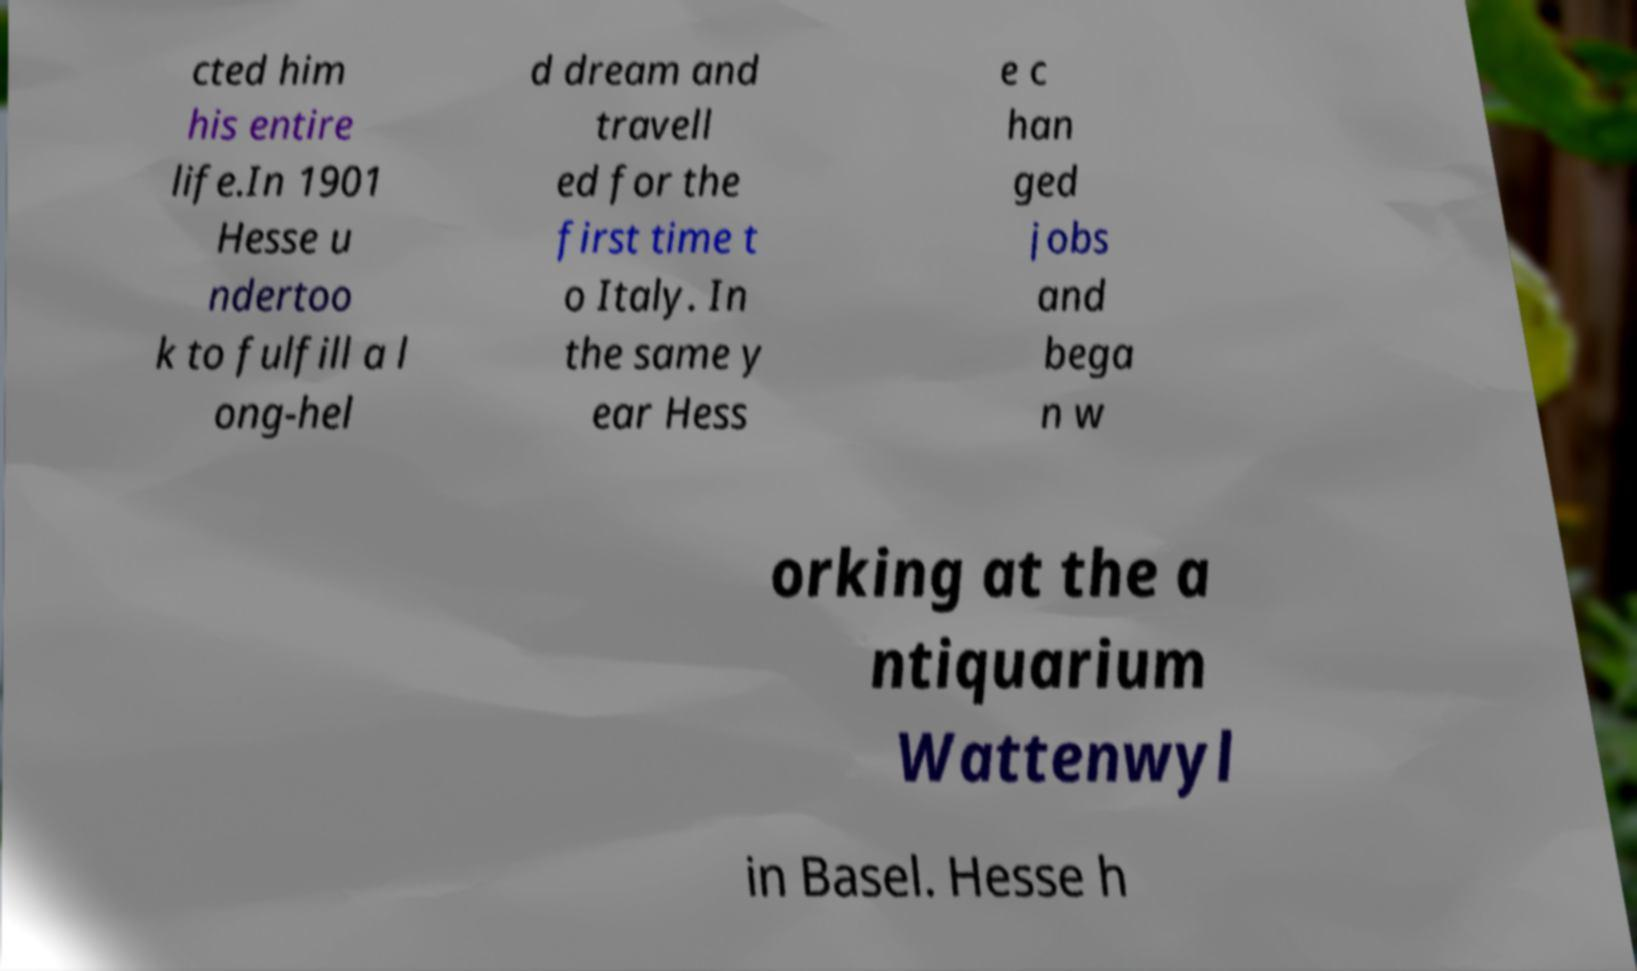There's text embedded in this image that I need extracted. Can you transcribe it verbatim? cted him his entire life.In 1901 Hesse u ndertoo k to fulfill a l ong-hel d dream and travell ed for the first time t o Italy. In the same y ear Hess e c han ged jobs and bega n w orking at the a ntiquarium Wattenwyl in Basel. Hesse h 